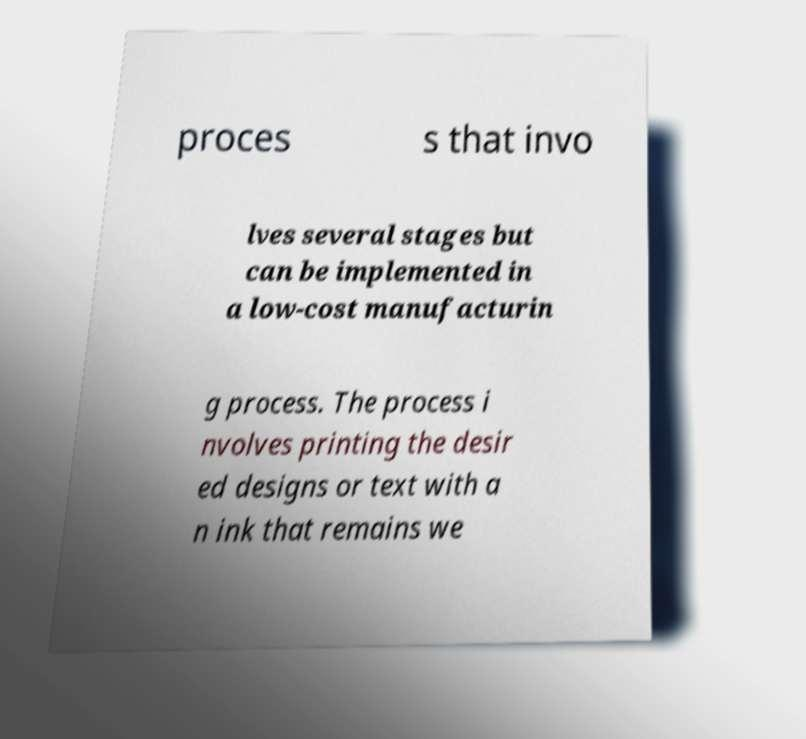I need the written content from this picture converted into text. Can you do that? proces s that invo lves several stages but can be implemented in a low-cost manufacturin g process. The process i nvolves printing the desir ed designs or text with a n ink that remains we 